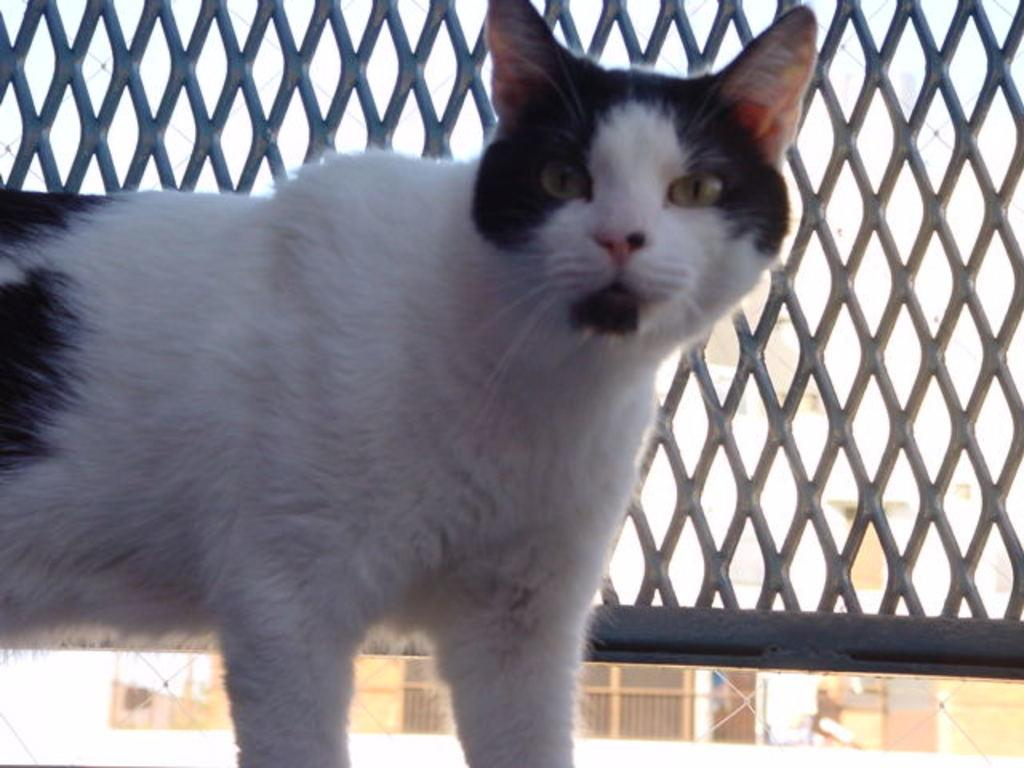What animal is in the front of the image? There is a cat in the front of the image. What is located in the front of the image alongside the cat? There is a fence in the front of the image. What type of structures can be seen in the background of the image? There are houses in the background of the image. What type of calculator can be seen on the cat's back in the image? There is no calculator present on the cat's back in the image. 